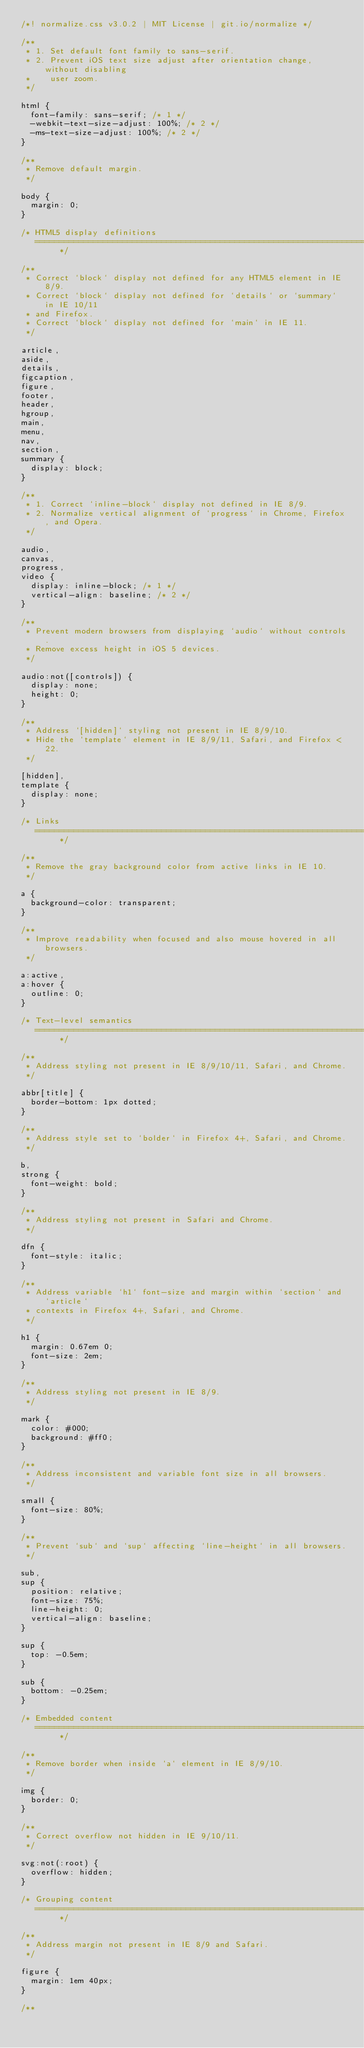<code> <loc_0><loc_0><loc_500><loc_500><_CSS_>/*! normalize.css v3.0.2 | MIT License | git.io/normalize */

/**
 * 1. Set default font family to sans-serif.
 * 2. Prevent iOS text size adjust after orientation change, without disabling
 *    user zoom.
 */

html {
  font-family: sans-serif; /* 1 */
  -webkit-text-size-adjust: 100%; /* 2 */
  -ms-text-size-adjust: 100%; /* 2 */
}

/**
 * Remove default margin.
 */

body {
  margin: 0;
}

/* HTML5 display definitions
   ========================================================================== */

/**
 * Correct `block` display not defined for any HTML5 element in IE 8/9.
 * Correct `block` display not defined for `details` or `summary` in IE 10/11
 * and Firefox.
 * Correct `block` display not defined for `main` in IE 11.
 */

article,
aside,
details,
figcaption,
figure,
footer,
header,
hgroup,
main,
menu,
nav,
section,
summary {
  display: block;
}

/**
 * 1. Correct `inline-block` display not defined in IE 8/9.
 * 2. Normalize vertical alignment of `progress` in Chrome, Firefox, and Opera.
 */

audio,
canvas,
progress,
video {
  display: inline-block; /* 1 */
  vertical-align: baseline; /* 2 */
}

/**
 * Prevent modern browsers from displaying `audio` without controls.
 * Remove excess height in iOS 5 devices.
 */

audio:not([controls]) {
  display: none;
  height: 0;
}

/**
 * Address `[hidden]` styling not present in IE 8/9/10.
 * Hide the `template` element in IE 8/9/11, Safari, and Firefox < 22.
 */

[hidden],
template {
  display: none;
}

/* Links
   ========================================================================== */

/**
 * Remove the gray background color from active links in IE 10.
 */

a {
  background-color: transparent;
}

/**
 * Improve readability when focused and also mouse hovered in all browsers.
 */

a:active,
a:hover {
  outline: 0;
}

/* Text-level semantics
   ========================================================================== */

/**
 * Address styling not present in IE 8/9/10/11, Safari, and Chrome.
 */

abbr[title] {
  border-bottom: 1px dotted;
}

/**
 * Address style set to `bolder` in Firefox 4+, Safari, and Chrome.
 */

b,
strong {
  font-weight: bold;
}

/**
 * Address styling not present in Safari and Chrome.
 */

dfn {
  font-style: italic;
}

/**
 * Address variable `h1` font-size and margin within `section` and `article`
 * contexts in Firefox 4+, Safari, and Chrome.
 */

h1 {
  margin: 0.67em 0;
  font-size: 2em;
}

/**
 * Address styling not present in IE 8/9.
 */

mark {
  color: #000;
  background: #ff0;
}

/**
 * Address inconsistent and variable font size in all browsers.
 */

small {
  font-size: 80%;
}

/**
 * Prevent `sub` and `sup` affecting `line-height` in all browsers.
 */

sub,
sup {
  position: relative;
  font-size: 75%;
  line-height: 0;
  vertical-align: baseline;
}

sup {
  top: -0.5em;
}

sub {
  bottom: -0.25em;
}

/* Embedded content
   ========================================================================== */

/**
 * Remove border when inside `a` element in IE 8/9/10.
 */

img {
  border: 0;
}

/**
 * Correct overflow not hidden in IE 9/10/11.
 */

svg:not(:root) {
  overflow: hidden;
}

/* Grouping content
   ========================================================================== */

/**
 * Address margin not present in IE 8/9 and Safari.
 */

figure {
  margin: 1em 40px;
}

/**</code> 